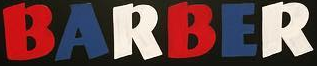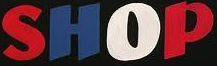What words can you see in these images in sequence, separated by a semicolon? BARBER; SHOP 